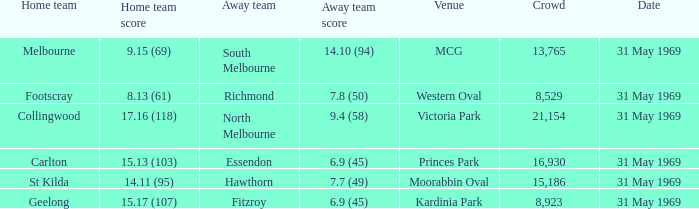11 (95)? St Kilda. 